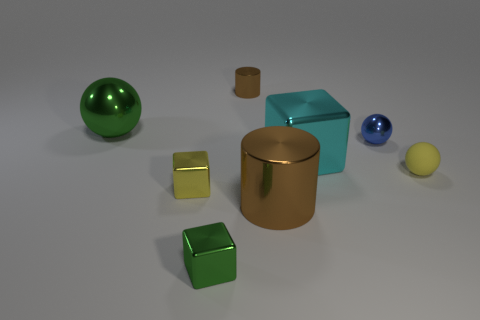Add 2 cyan cylinders. How many objects exist? 10 Subtract all spheres. How many objects are left? 5 Add 5 large things. How many large things exist? 8 Subtract 0 red spheres. How many objects are left? 8 Subtract all tiny purple objects. Subtract all blue balls. How many objects are left? 7 Add 1 blue metallic spheres. How many blue metallic spheres are left? 2 